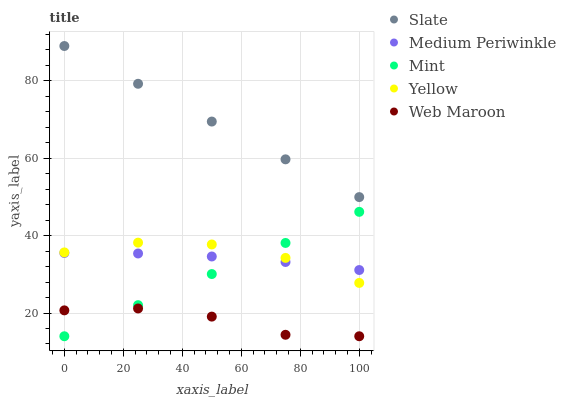Does Web Maroon have the minimum area under the curve?
Answer yes or no. Yes. Does Slate have the maximum area under the curve?
Answer yes or no. Yes. Does Mint have the minimum area under the curve?
Answer yes or no. No. Does Mint have the maximum area under the curve?
Answer yes or no. No. Is Slate the smoothest?
Answer yes or no. Yes. Is Web Maroon the roughest?
Answer yes or no. Yes. Is Mint the smoothest?
Answer yes or no. No. Is Mint the roughest?
Answer yes or no. No. Does Web Maroon have the lowest value?
Answer yes or no. Yes. Does Slate have the lowest value?
Answer yes or no. No. Does Slate have the highest value?
Answer yes or no. Yes. Does Mint have the highest value?
Answer yes or no. No. Is Web Maroon less than Slate?
Answer yes or no. Yes. Is Slate greater than Yellow?
Answer yes or no. Yes. Does Web Maroon intersect Mint?
Answer yes or no. Yes. Is Web Maroon less than Mint?
Answer yes or no. No. Is Web Maroon greater than Mint?
Answer yes or no. No. Does Web Maroon intersect Slate?
Answer yes or no. No. 